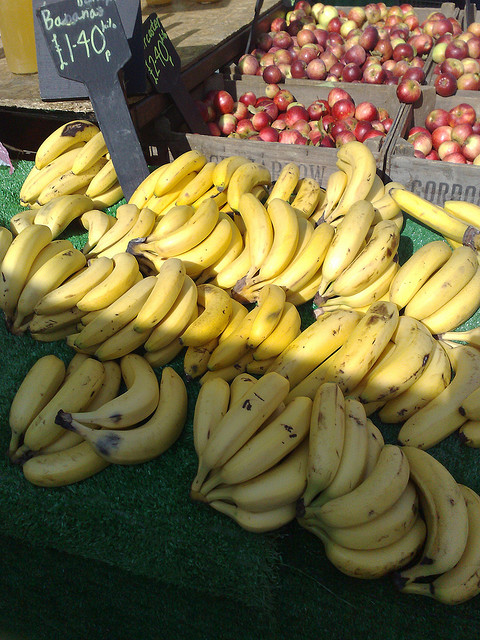How many apples are there? There seem to be no apples visible in the image. The picture actually shows a bunch of bananas on the left and some red fruits, possibly apples, on a stand in the background to the right, but they are not the main focus. 